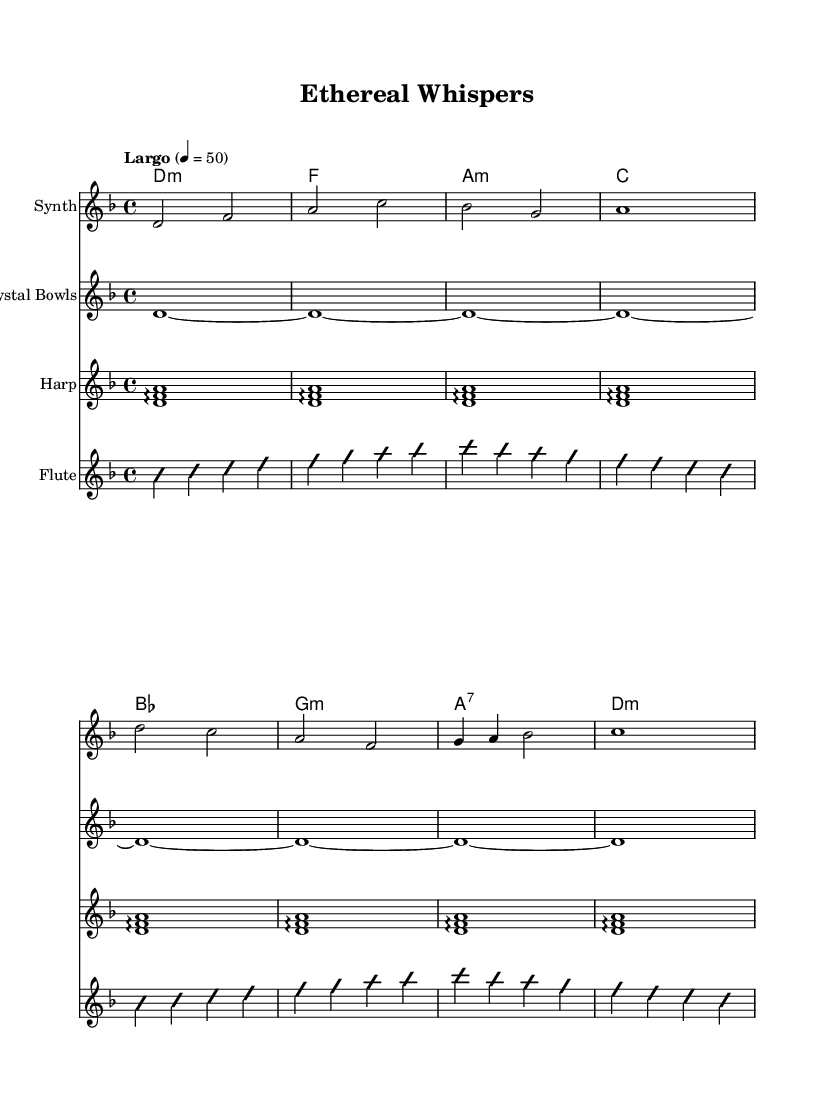What is the key signature of this music? The key signature is D minor, which has one flat (B flat). It is determined by looking at the key signature indicated at the beginning of the staff.
Answer: D minor What is the time signature of this music? The time signature is 4/4, which indicates that there are four beats in each measure and the quarter note gets one beat. It is visible at the beginning of the score.
Answer: 4/4 What tempo is indicated for this score? The tempo indicated is "Largo" with a quarter note equaling 50 beats per minute. This is noted in the tempo marking at the beginning of the score.
Answer: Largo How many measures are in the melody section? There are eight measures in the melody section, as counted from the beginning of the melody to the end. Each measure is separated by vertical lines.
Answer: Eight Which instrument is playing the melody? The melody is played by the Synth, as indicated by the instrument name above the staff where the melody is written.
Answer: Synth What type of chords are used in the harmony section? The harmony section contains minor and major chords, as seen from the chord symbols (e.g., D minor, A minor, G minor) written above the staff.
Answer: Minor and major Is there any improvisation indicated in the flute part? Yes, there is an indication of improvisation in the flute part, indicated by the terms "improvisationOn" and "improvisationOff" before and after the flute notes.
Answer: Yes 